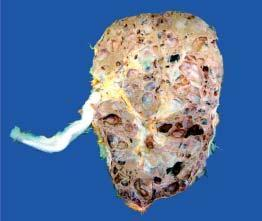re the renal pelvis and calyces distorted due to cystic change?
Answer the question using a single word or phrase. Yes 